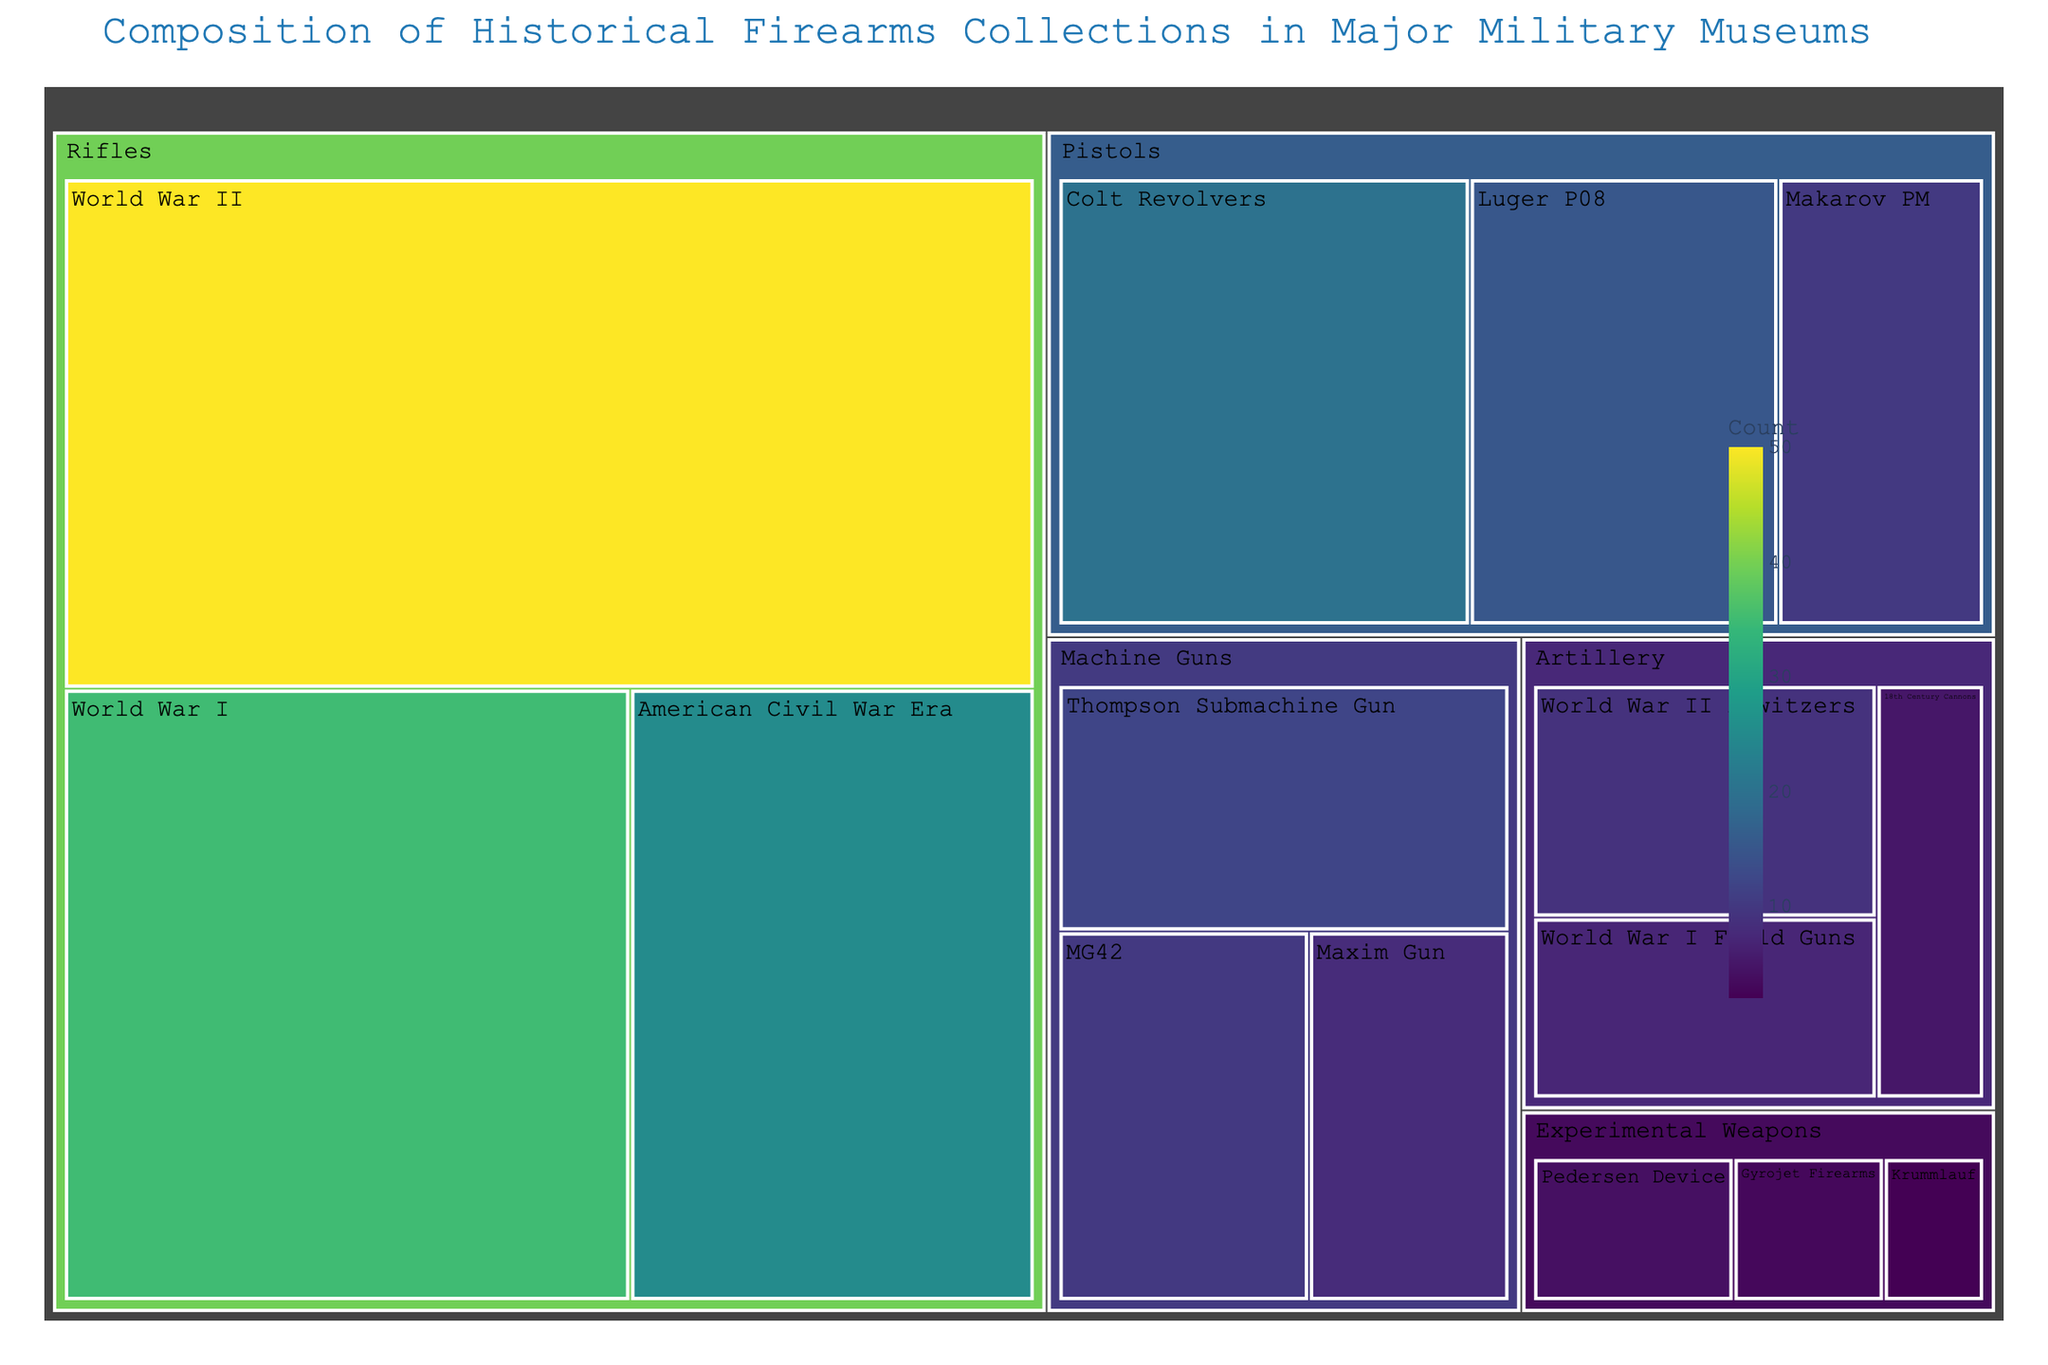What's the title of the treemap? The title of the plot is a key visual element and is usually placed at the top of the figure.
Answer: Composition of Historical Firearms Collections in Major Military Museums How many subcategories are there under the "Rifles" category? The "Rifles" category has three subcategories that can be observed by looking at the branching in the treemap.
Answer: 3 Which subcategory under "Machine Guns" has the highest count? Examine the "Machine Guns" category and compare the values of its subcategories to determine the highest count.
Answer: Thompson Submachine Gun What is the total count of firearms in the "Artillery" category? Sum the values of all subcategories under the "Artillery" category: 5 (18th Century Cannons) + 7 (World War I Field Guns) + 9 (World War II Howitzers).
Answer: 21 Which has more collections, "World War II Rifles" or "World War II Howitzers"? Compare the counts of "World War II Rifles" (50) and "World War II Howitzers" (9) by using their respective values shown in the treemap.
Answer: World War II Rifles What is the smallest category by total count? Add the counts of subcategories under each main category, and identify the smallest sum. This requires examining all categories like Rifles, Pistols, Machine Guns, etc., and then finding the smallest total.
Answer: Experimental Weapons How does the collection size of "Colt Revolvers" compare to "Luger P08"? Compare the count of "Colt Revolvers" (20) with "Luger P08" (15) by looking at their values in the "Pistols" category on the treemap.
Answer: Colt Revolvers has more What is the total count of all firearms in the treemap? Sum all the values in the treemap across all categories and subcategories to find the total count. The values to add are 25, 35, 50, 20, 15, 10, 8, 12, 10, 5, 7, 9, 3, 2, 4. Thus, the total is 25+35+50+20+15+10+8+12+10+5+7+9+3+2+4=215.
Answer: 215 Which subcategory has less than 5 collections? Identify subcategories showing values less than 5 by browsing the text labels on the treemap. These are Gyrojet Firearms (3), Krummlauf (2), and Pedersen Device (4) under "Experimental Weapons."
Answer: Gyrojet Firearms, Krummlauf, Pedersen Device 